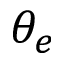Convert formula to latex. <formula><loc_0><loc_0><loc_500><loc_500>\theta _ { e }</formula> 